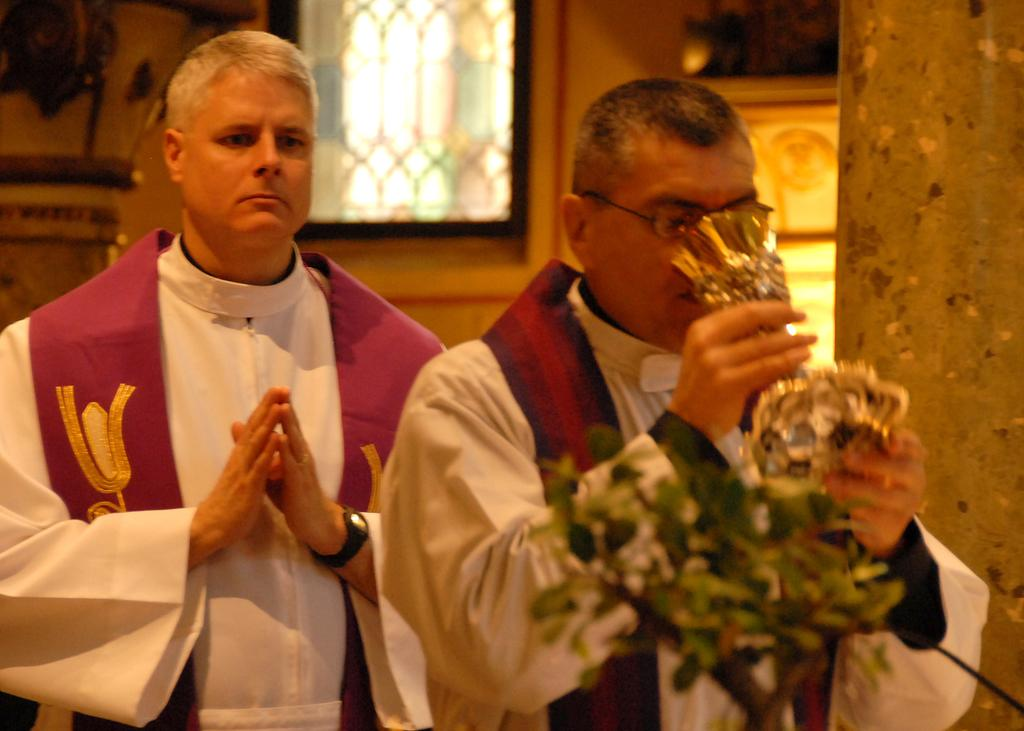How many people are in the image? There are two men standing in the image. What is one of the men holding? One of the men is holding a glass. What type of vegetation is present in the image? There is a plant in the image. What architectural features can be seen in the image? There is a wall and a window in the image. How many clocks are visible in the image? There are no clocks present in the image. What type of power source is being used by the men in the image? There is no information about power sources in the image. 